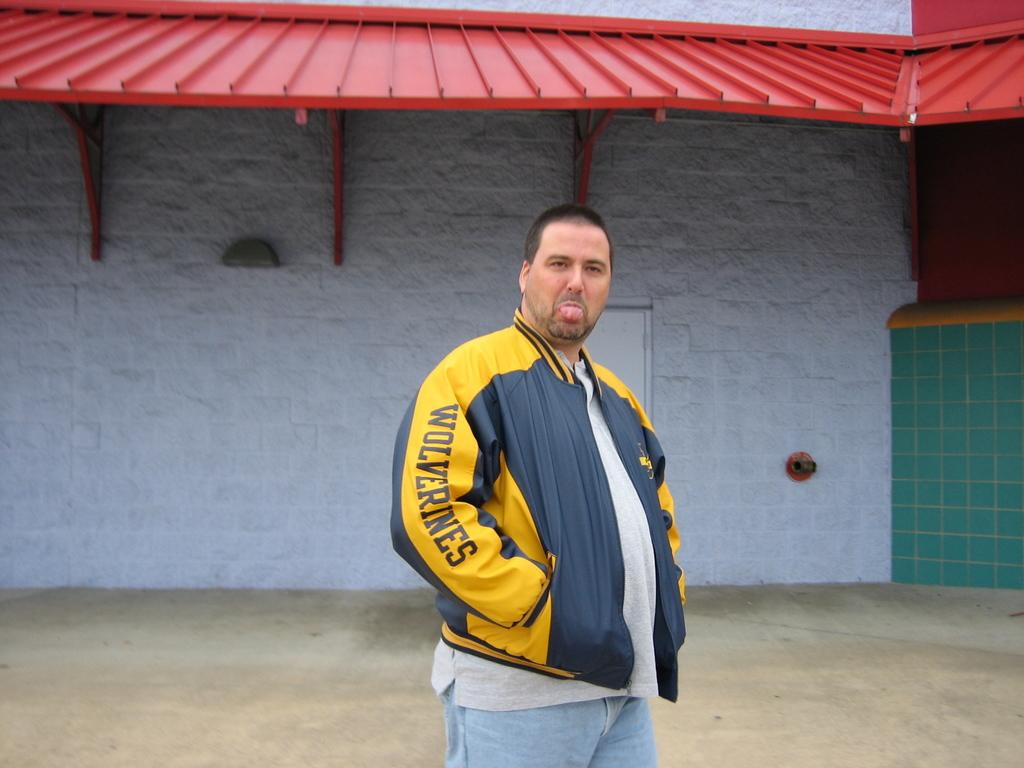Who is present in the image? There is a man in the image. What is the man wearing? The man is wearing a yellow coat. What can be seen behind the man? There is a wall behind the man. What color is the wall? The wall is white in color. What type of club does the man's son belong to in the image? There is no mention of a son or a club in the image. 